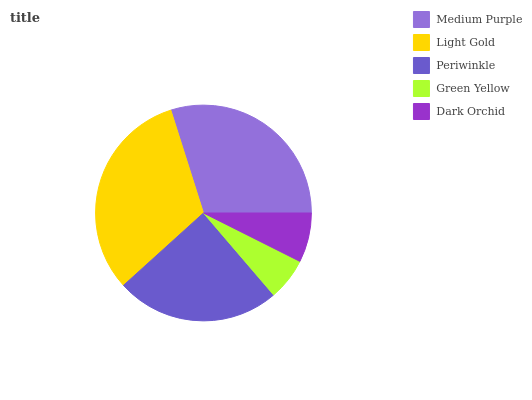Is Green Yellow the minimum?
Answer yes or no. Yes. Is Light Gold the maximum?
Answer yes or no. Yes. Is Periwinkle the minimum?
Answer yes or no. No. Is Periwinkle the maximum?
Answer yes or no. No. Is Light Gold greater than Periwinkle?
Answer yes or no. Yes. Is Periwinkle less than Light Gold?
Answer yes or no. Yes. Is Periwinkle greater than Light Gold?
Answer yes or no. No. Is Light Gold less than Periwinkle?
Answer yes or no. No. Is Periwinkle the high median?
Answer yes or no. Yes. Is Periwinkle the low median?
Answer yes or no. Yes. Is Green Yellow the high median?
Answer yes or no. No. Is Light Gold the low median?
Answer yes or no. No. 